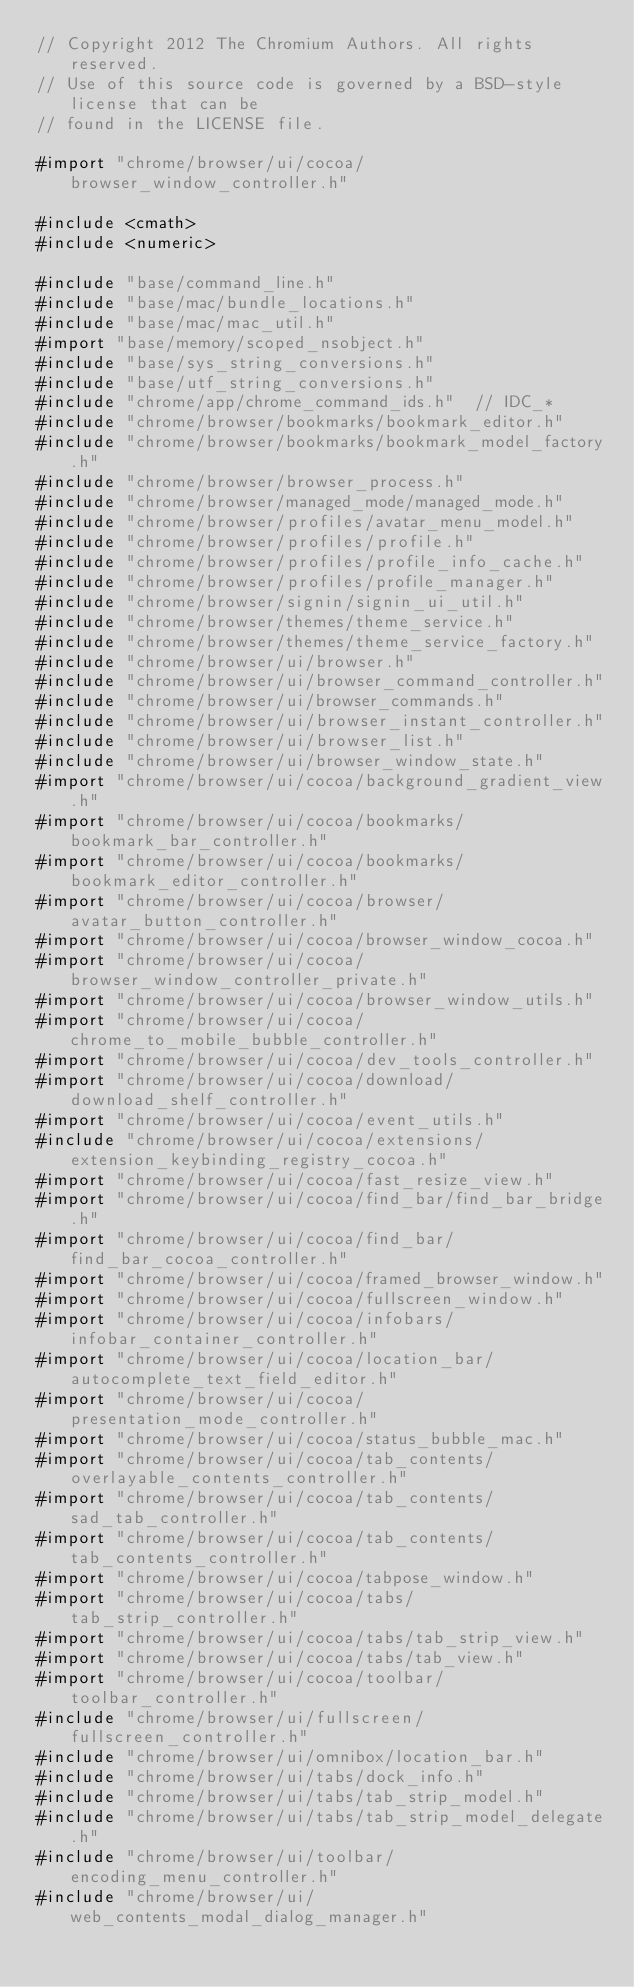Convert code to text. <code><loc_0><loc_0><loc_500><loc_500><_ObjectiveC_>// Copyright 2012 The Chromium Authors. All rights reserved.
// Use of this source code is governed by a BSD-style license that can be
// found in the LICENSE file.

#import "chrome/browser/ui/cocoa/browser_window_controller.h"

#include <cmath>
#include <numeric>

#include "base/command_line.h"
#include "base/mac/bundle_locations.h"
#include "base/mac/mac_util.h"
#import "base/memory/scoped_nsobject.h"
#include "base/sys_string_conversions.h"
#include "base/utf_string_conversions.h"
#include "chrome/app/chrome_command_ids.h"  // IDC_*
#include "chrome/browser/bookmarks/bookmark_editor.h"
#include "chrome/browser/bookmarks/bookmark_model_factory.h"
#include "chrome/browser/browser_process.h"
#include "chrome/browser/managed_mode/managed_mode.h"
#include "chrome/browser/profiles/avatar_menu_model.h"
#include "chrome/browser/profiles/profile.h"
#include "chrome/browser/profiles/profile_info_cache.h"
#include "chrome/browser/profiles/profile_manager.h"
#include "chrome/browser/signin/signin_ui_util.h"
#include "chrome/browser/themes/theme_service.h"
#include "chrome/browser/themes/theme_service_factory.h"
#include "chrome/browser/ui/browser.h"
#include "chrome/browser/ui/browser_command_controller.h"
#include "chrome/browser/ui/browser_commands.h"
#include "chrome/browser/ui/browser_instant_controller.h"
#include "chrome/browser/ui/browser_list.h"
#include "chrome/browser/ui/browser_window_state.h"
#import "chrome/browser/ui/cocoa/background_gradient_view.h"
#import "chrome/browser/ui/cocoa/bookmarks/bookmark_bar_controller.h"
#import "chrome/browser/ui/cocoa/bookmarks/bookmark_editor_controller.h"
#import "chrome/browser/ui/cocoa/browser/avatar_button_controller.h"
#import "chrome/browser/ui/cocoa/browser_window_cocoa.h"
#import "chrome/browser/ui/cocoa/browser_window_controller_private.h"
#import "chrome/browser/ui/cocoa/browser_window_utils.h"
#import "chrome/browser/ui/cocoa/chrome_to_mobile_bubble_controller.h"
#import "chrome/browser/ui/cocoa/dev_tools_controller.h"
#import "chrome/browser/ui/cocoa/download/download_shelf_controller.h"
#import "chrome/browser/ui/cocoa/event_utils.h"
#include "chrome/browser/ui/cocoa/extensions/extension_keybinding_registry_cocoa.h"
#import "chrome/browser/ui/cocoa/fast_resize_view.h"
#import "chrome/browser/ui/cocoa/find_bar/find_bar_bridge.h"
#import "chrome/browser/ui/cocoa/find_bar/find_bar_cocoa_controller.h"
#import "chrome/browser/ui/cocoa/framed_browser_window.h"
#import "chrome/browser/ui/cocoa/fullscreen_window.h"
#import "chrome/browser/ui/cocoa/infobars/infobar_container_controller.h"
#import "chrome/browser/ui/cocoa/location_bar/autocomplete_text_field_editor.h"
#import "chrome/browser/ui/cocoa/presentation_mode_controller.h"
#import "chrome/browser/ui/cocoa/status_bubble_mac.h"
#import "chrome/browser/ui/cocoa/tab_contents/overlayable_contents_controller.h"
#import "chrome/browser/ui/cocoa/tab_contents/sad_tab_controller.h"
#import "chrome/browser/ui/cocoa/tab_contents/tab_contents_controller.h"
#import "chrome/browser/ui/cocoa/tabpose_window.h"
#import "chrome/browser/ui/cocoa/tabs/tab_strip_controller.h"
#import "chrome/browser/ui/cocoa/tabs/tab_strip_view.h"
#import "chrome/browser/ui/cocoa/tabs/tab_view.h"
#import "chrome/browser/ui/cocoa/toolbar/toolbar_controller.h"
#include "chrome/browser/ui/fullscreen/fullscreen_controller.h"
#include "chrome/browser/ui/omnibox/location_bar.h"
#include "chrome/browser/ui/tabs/dock_info.h"
#include "chrome/browser/ui/tabs/tab_strip_model.h"
#include "chrome/browser/ui/tabs/tab_strip_model_delegate.h"
#include "chrome/browser/ui/toolbar/encoding_menu_controller.h"
#include "chrome/browser/ui/web_contents_modal_dialog_manager.h"</code> 